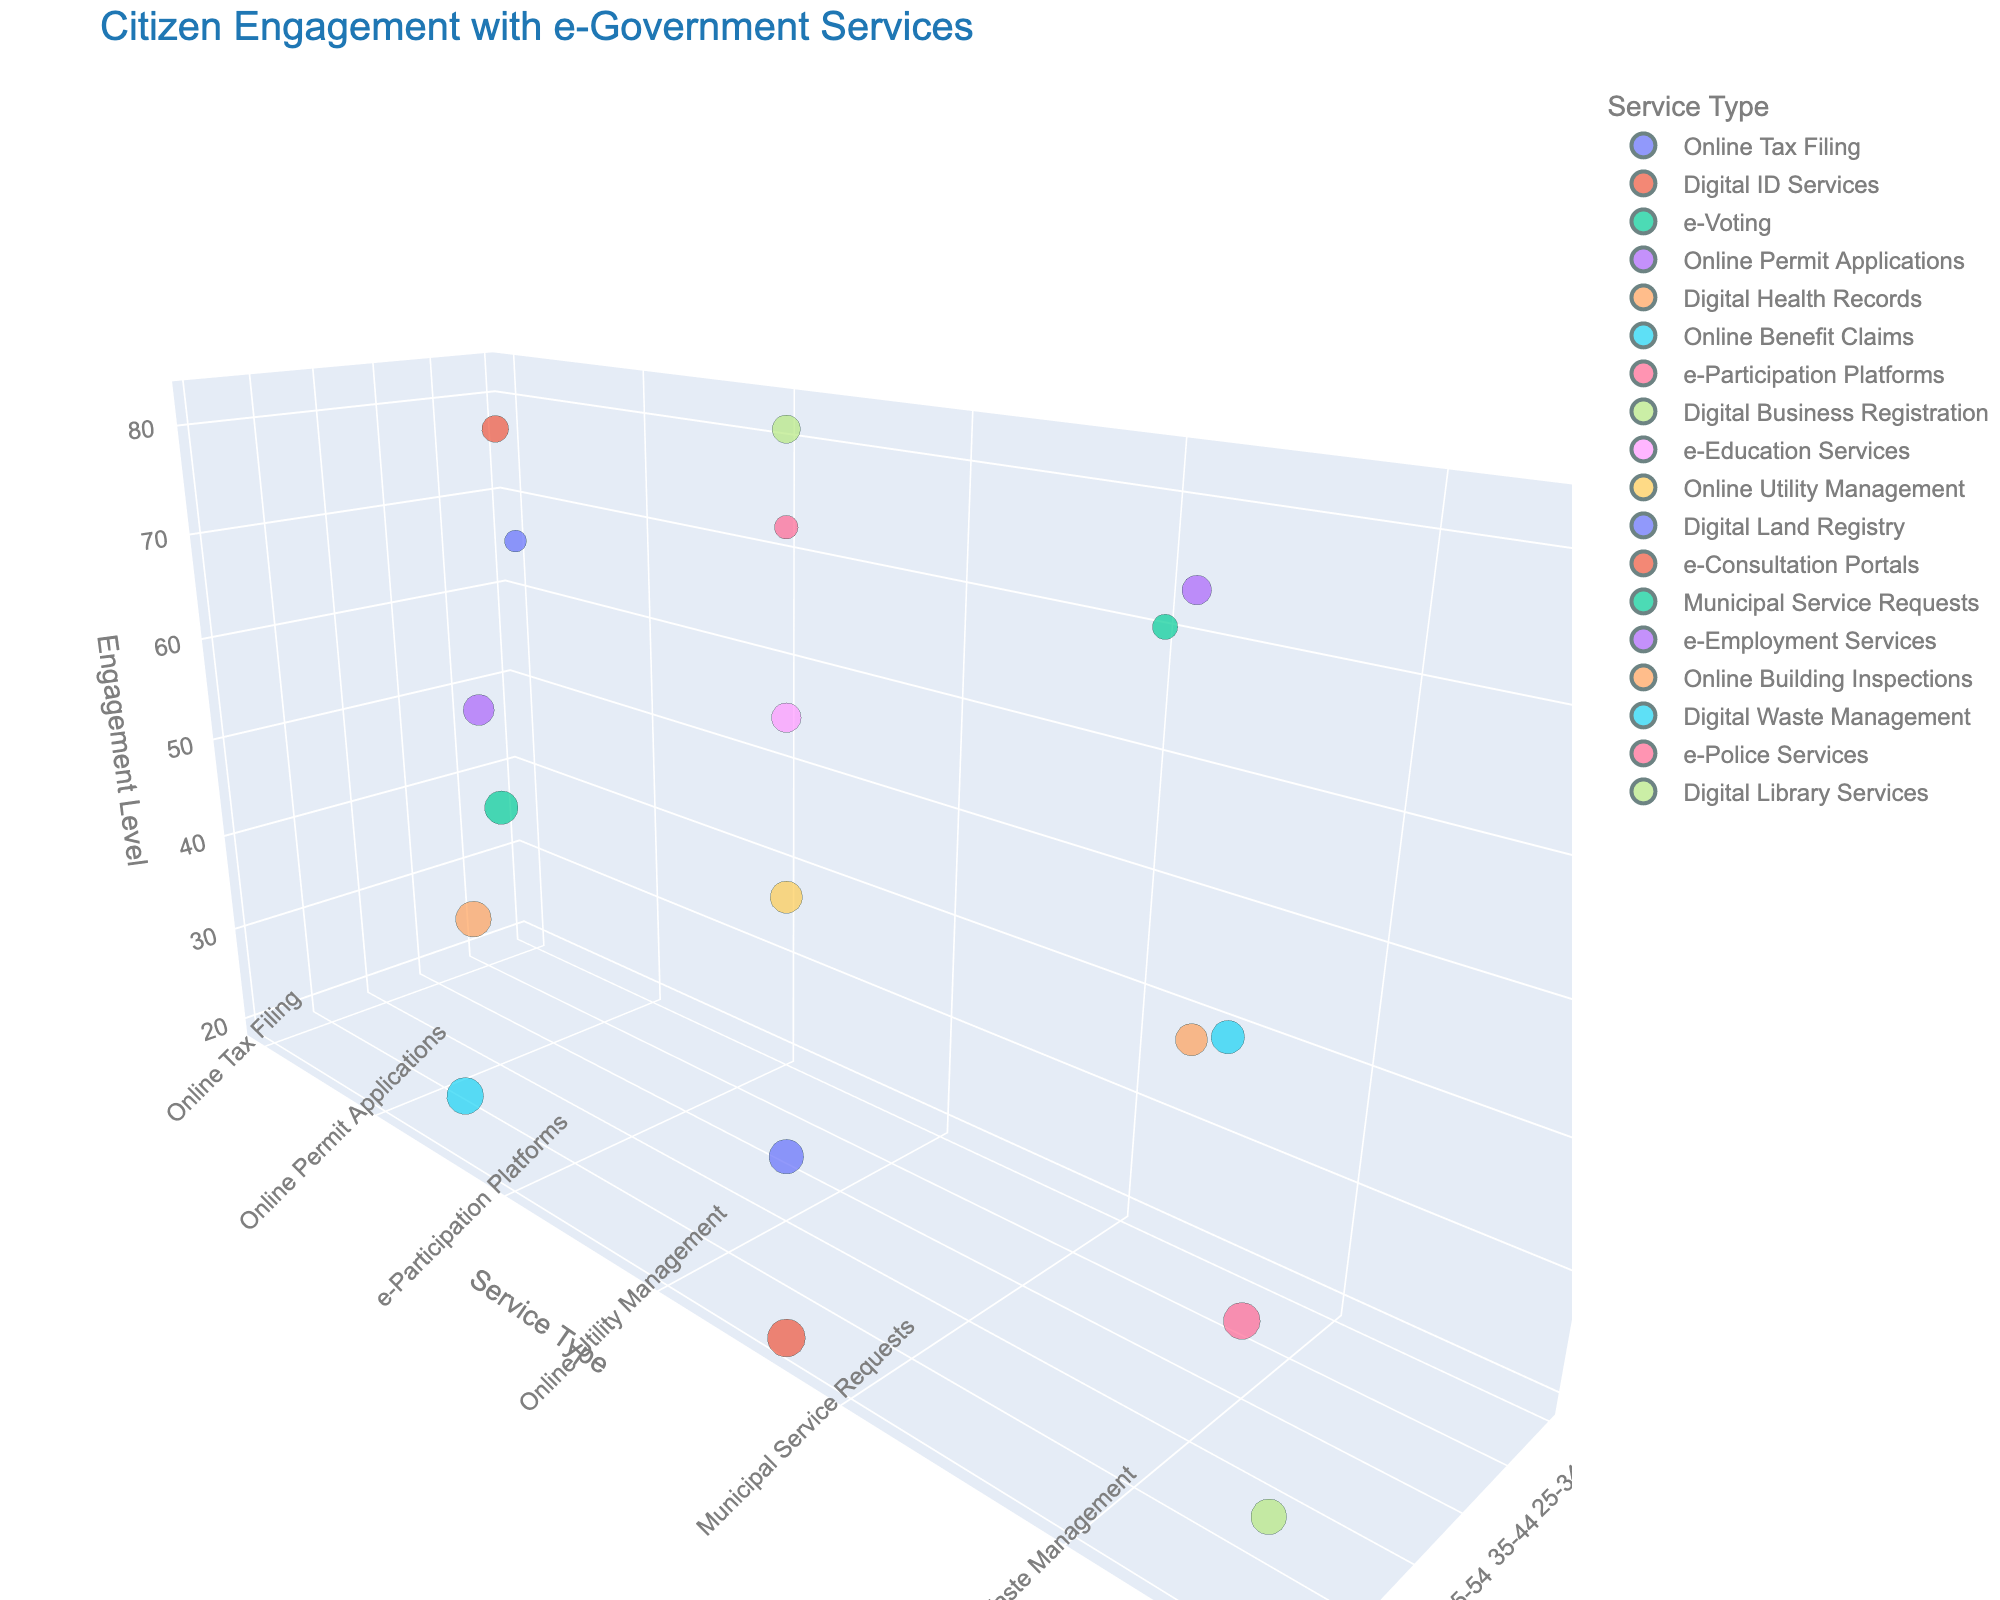How many Age Groups are represented in the chart? Look at the x-axis labeled 'Age Group' and count the unique age groups.
Answer: 6 What is the title of the chart? The title is usually displayed at the top of the chart.
Answer: Citizen Engagement with e-Government Services Which Age Group has the highest Engagement Level for Online Benefit Claims? Locate 'Online Benefit Claims' on the y-axis and look for the highest point on the z-axis in that row. Check the corresponding Age Group on the x-axis.
Answer: 65+ Compare the Privacy Concern Level for Digital Health Records and e-Police Services for the 55-64 Age Group. Which one is higher? Locate the data points for 'Digital Health Records' and 'e-Police Services' in the 55-64 Age Group and compare the size of the bubbles, which represents the Privacy Concern Level.
Answer: e-Police Services What is the average Engagement Level for the services in the 25-34 Age Group? Find the Engagement Level (z-axis) for all services in the 25-34 Age Group and calculate the average. (78 + 82 + 75) / 3 = 78.3
Answer: 78.3 Which Service Type has the lowest Privacy Concern Level across all Age Groups? Compare the bubble sizes representing Privacy Concern Levels for each Service Type and find the smallest one.
Answer: Online Tax Filing Is there a trend in Privacy Concern Level with age for e-Consultation Portals? Observe the size of the bubbles representing Privacy Concern Levels for 'e-Consultation Portals' across different Age Groups.
Answer: Increasing What Service Type shows the highest Engagement Level for the 18-24 Age Group? Find the data points in the 18-24 Age Group and look for the highest point on the z-axis.
Answer: e-Participation Platforms Which Age Group shows the least engagement with Digital Land Registry services? Locate 'Digital Land Registry' on the y-axis and find the lowest point on the z-axis. Check the corresponding Age Group on the x-axis.
Answer: 55-64 